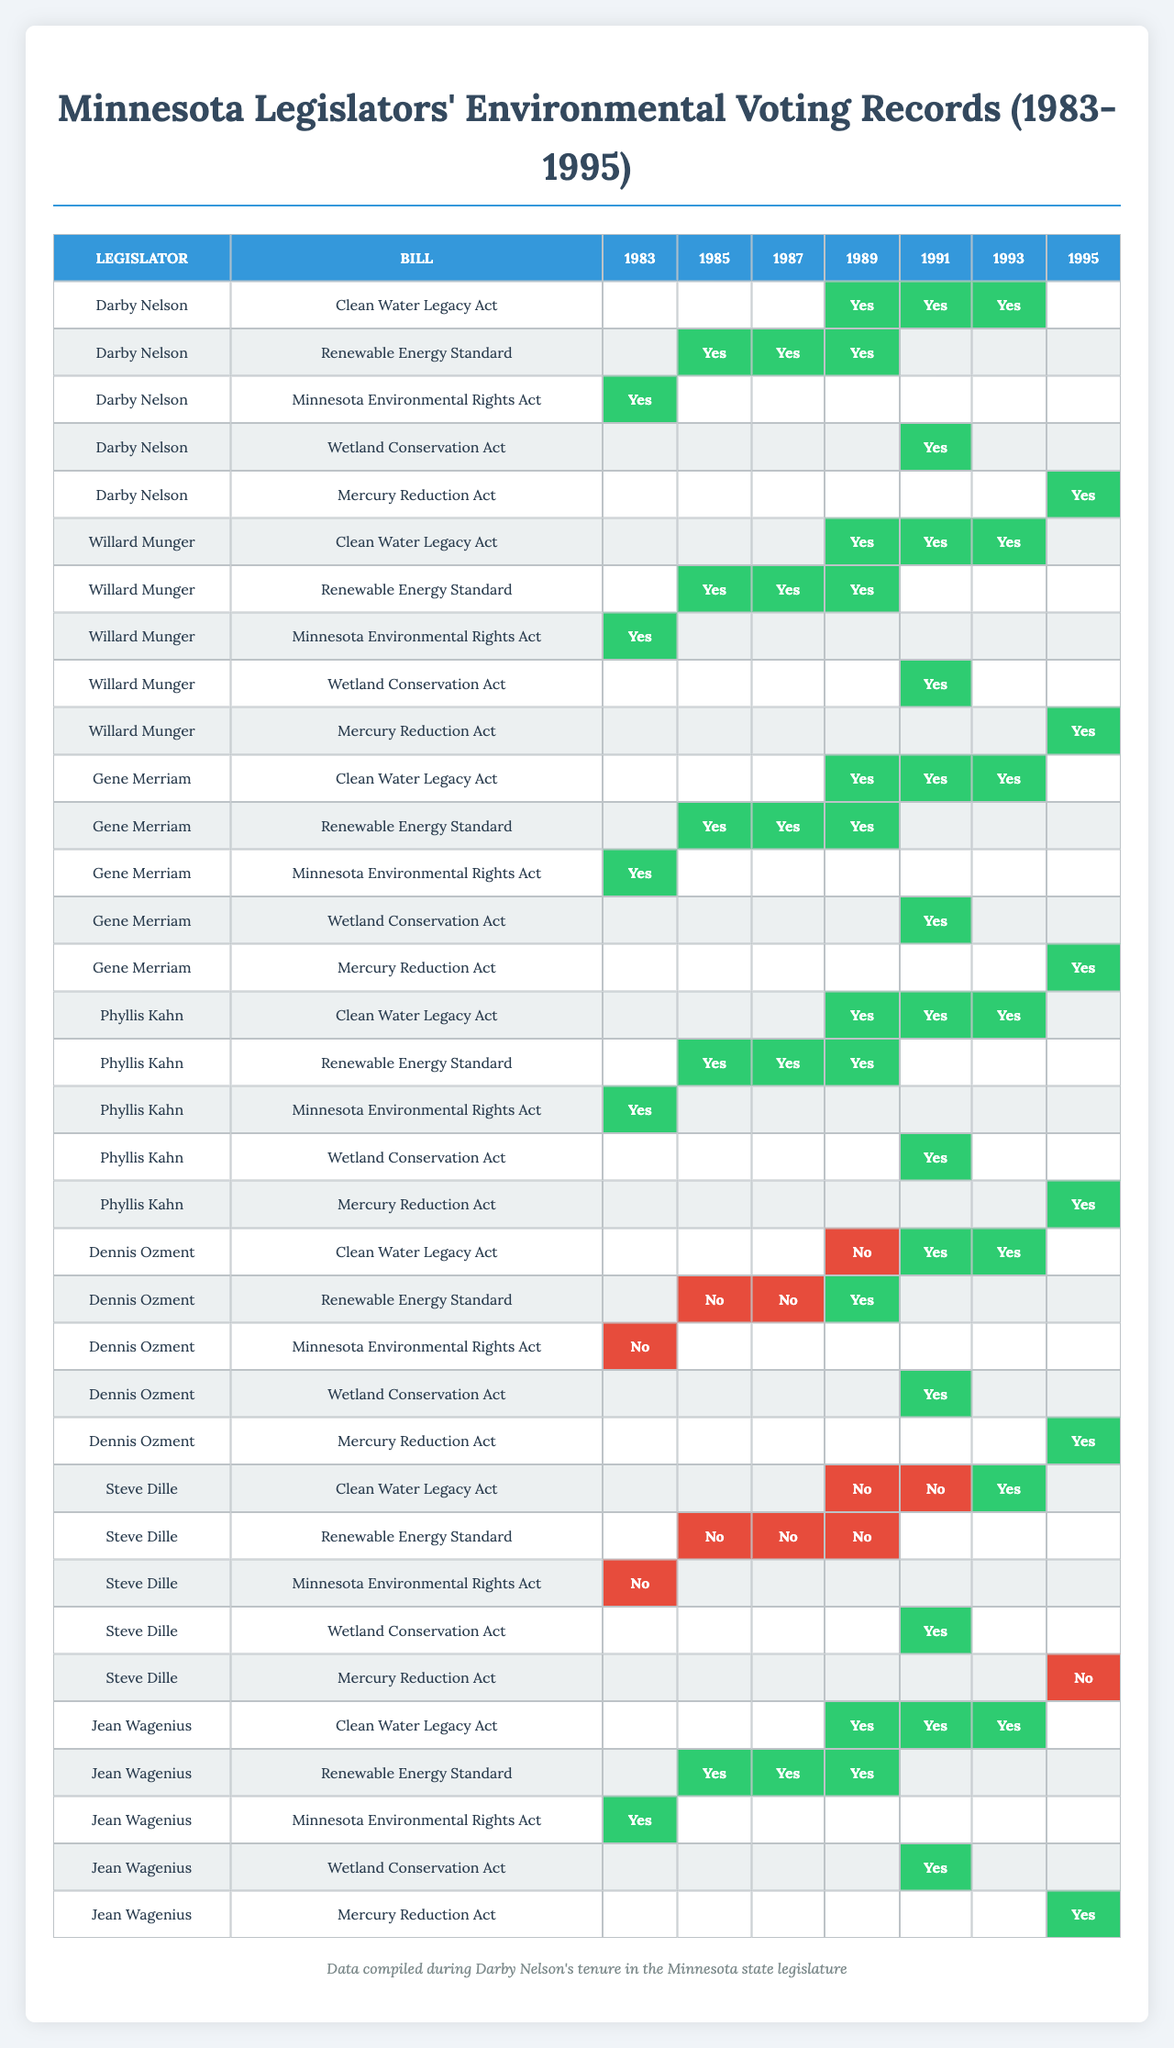What was Darby Nelson's voting record on the Clean Water Legacy Act in 1989? According to the table, Darby Nelson voted "Yes" for the Clean Water Legacy Act in 1989.
Answer: Yes How many times did Darby Nelson vote "Yes" on environmental bills in the 1990s? Reviewing the votes from the 1990s, Darby Nelson voted "Yes" three times: for the Clean Water Legacy Act in 1991 and 1993, and for the Mercury Reduction Act in 1995.
Answer: 3 Did Dennis Ozment vote "Yes" on the Renewable Energy Standard in 1987? The table indicates that Dennis Ozment voted "No" on the Renewable Energy Standard in 1987.
Answer: No Which legislator had the most consistent "Yes" votes across all environmental bills? Analyzing the votes, we can see that Jean Wagenius consistently voted "Yes" for all environmental bills listed across all years.
Answer: Jean Wagenius In which year did Steve Dille vote the least favorably for the Clean Water Legacy Act? According to the table, Steve Dille voted "No" for the Clean Water Legacy Act in 1989 and 1991 but voted "Yes" in 1993. Thus, he voted least favorably in 1989.
Answer: 1989 What percentage of environmental bills did Gene Merriam vote "Yes" on during his tenure as a legislator? Gene Merriam voted "Yes" on all five environmental bills during the years listed. Since he voted "Yes" for 5 out of 5 bills, the percentage is (5/5) * 100 = 100%.
Answer: 100% Was there any bill on which Dennis Ozment and Steve Dille both voted "Yes"? Checking the table, the only environment bill that both Dennis Ozment and Steve Dille voted "Yes" on is the Wetland Conservation Act in 1991.
Answer: Yes Compare the votes of Dennis Ozment and Steve Dille on the Mercury Reduction Act. Who had a more favorable vote? Dennis Ozment voted "Yes" on the Mercury Reduction Act in 1995, while Steve Dille voted "No." Therefore, Dennis Ozment had the more favorable vote.
Answer: Dennis Ozment What is the variance in the number of "Yes" votes for the Clean Water Legacy Act among the legislators? The counts of "Yes" votes for the Clean Water Legacy Act are 5 for both Darby Nelson, Willard Munger, Gene Merriam, Phyllis Kahn, and 2 for Dennis Ozment and Steve Dille, and 5 for Jean Wagenius. The variance is calculated as follows: mean = 5, variance = ((5-5)² + (5-5)² + (5-5)² + (5-5)² + (2-5)² + (2-5)² + (5-5)²) / 7 = 3.
Answer: 3 Overall, how did the votes on environmental bills trend over the years for the legislators? Observing the table, it appears that most legislators showed increasing support for environmental bills over the years, particularly from 1989 onwards, with very few "No" votes in the 1990s.
Answer: Increasing support 